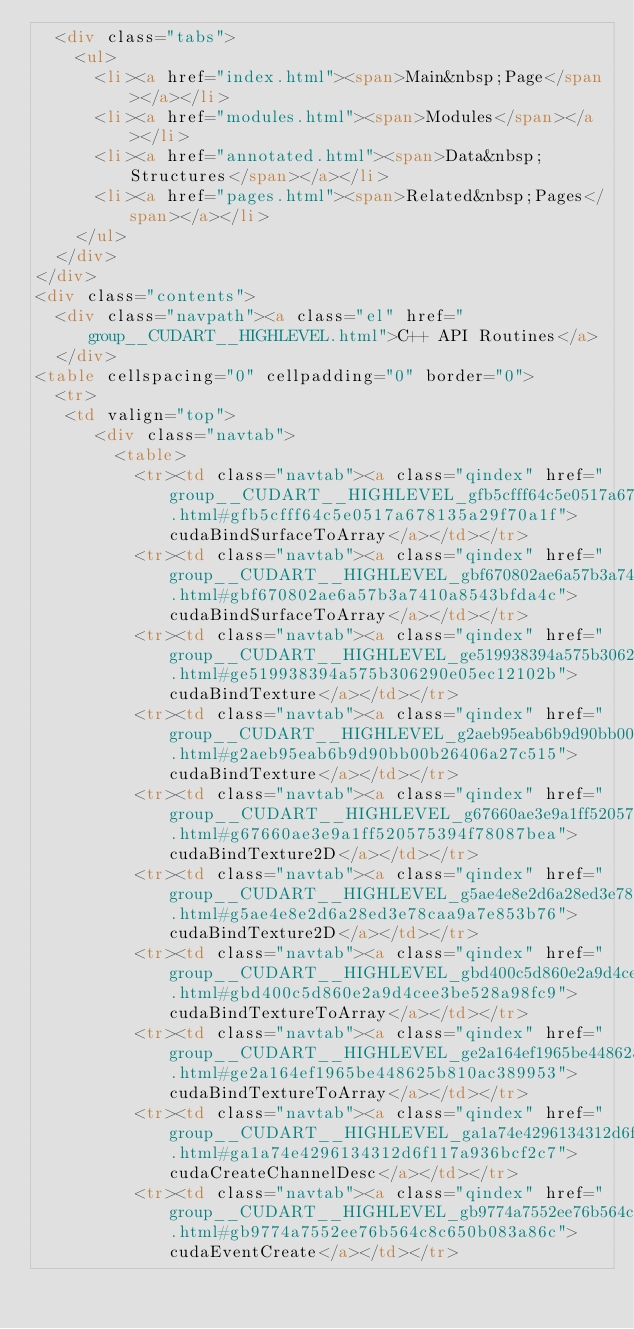Convert code to text. <code><loc_0><loc_0><loc_500><loc_500><_HTML_>  <div class="tabs">
    <ul>
      <li><a href="index.html"><span>Main&nbsp;Page</span></a></li>
      <li><a href="modules.html"><span>Modules</span></a></li>
      <li><a href="annotated.html"><span>Data&nbsp;Structures</span></a></li>
      <li><a href="pages.html"><span>Related&nbsp;Pages</span></a></li>
    </ul>
  </div>
</div>
<div class="contents">
  <div class="navpath"><a class="el" href="group__CUDART__HIGHLEVEL.html">C++ API Routines</a>
  </div>
<table cellspacing="0" cellpadding="0" border="0">
  <tr>
   <td valign="top">
      <div class="navtab">
        <table>
          <tr><td class="navtab"><a class="qindex" href="group__CUDART__HIGHLEVEL_gfb5cfff64c5e0517a678135a29f70a1f.html#gfb5cfff64c5e0517a678135a29f70a1f">cudaBindSurfaceToArray</a></td></tr>
          <tr><td class="navtab"><a class="qindex" href="group__CUDART__HIGHLEVEL_gbf670802ae6a57b3a7410a8543bfda4c.html#gbf670802ae6a57b3a7410a8543bfda4c">cudaBindSurfaceToArray</a></td></tr>
          <tr><td class="navtab"><a class="qindex" href="group__CUDART__HIGHLEVEL_ge519938394a575b306290e05ec12102b.html#ge519938394a575b306290e05ec12102b">cudaBindTexture</a></td></tr>
          <tr><td class="navtab"><a class="qindex" href="group__CUDART__HIGHLEVEL_g2aeb95eab6b9d90bb00b26406a27c515.html#g2aeb95eab6b9d90bb00b26406a27c515">cudaBindTexture</a></td></tr>
          <tr><td class="navtab"><a class="qindex" href="group__CUDART__HIGHLEVEL_g67660ae3e9a1ff520575394f78087bea.html#g67660ae3e9a1ff520575394f78087bea">cudaBindTexture2D</a></td></tr>
          <tr><td class="navtab"><a class="qindex" href="group__CUDART__HIGHLEVEL_g5ae4e8e2d6a28ed3e78caa9a7e853b76.html#g5ae4e8e2d6a28ed3e78caa9a7e853b76">cudaBindTexture2D</a></td></tr>
          <tr><td class="navtab"><a class="qindex" href="group__CUDART__HIGHLEVEL_gbd400c5d860e2a9d4cee3be528a98fc9.html#gbd400c5d860e2a9d4cee3be528a98fc9">cudaBindTextureToArray</a></td></tr>
          <tr><td class="navtab"><a class="qindex" href="group__CUDART__HIGHLEVEL_ge2a164ef1965be448625b810ac389953.html#ge2a164ef1965be448625b810ac389953">cudaBindTextureToArray</a></td></tr>
          <tr><td class="navtab"><a class="qindex" href="group__CUDART__HIGHLEVEL_ga1a74e4296134312d6f117a936bcf2c7.html#ga1a74e4296134312d6f117a936bcf2c7">cudaCreateChannelDesc</a></td></tr>
          <tr><td class="navtab"><a class="qindex" href="group__CUDART__HIGHLEVEL_gb9774a7552ee76b564c8c650b083a86c.html#gb9774a7552ee76b564c8c650b083a86c">cudaEventCreate</a></td></tr></code> 